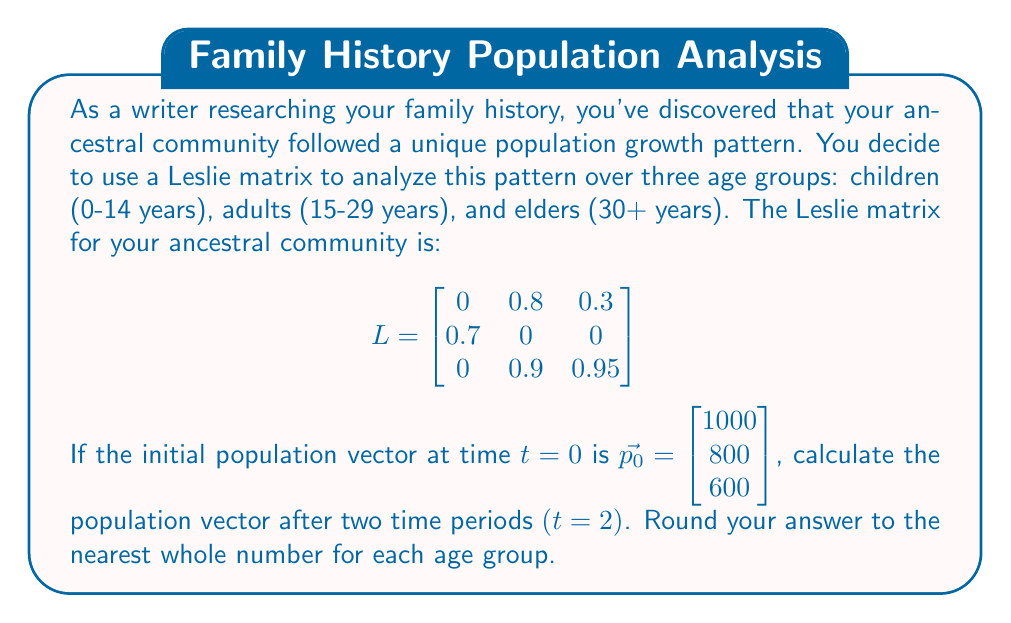Solve this math problem. To solve this problem, we need to multiply the Leslie matrix by the population vector twice, as we want to find the population after two time periods. Let's break it down step-by-step:

1) First, let's calculate the population after one time period $(t=1)$:

   $\vec{p_1} = L \cdot \vec{p_0}$

   $$\begin{bmatrix}
   0 & 0.8 & 0.3 \\
   0.7 & 0 & 0 \\
   0 & 0.9 & 0.95
   \end{bmatrix} \cdot \begin{bmatrix} 1000 \\ 800 \\ 600 \end{bmatrix}$$

   $$= \begin{bmatrix}
   (0 \cdot 1000) + (0.8 \cdot 800) + (0.3 \cdot 600) \\
   (0.7 \cdot 1000) + (0 \cdot 800) + (0 \cdot 600) \\
   (0 \cdot 1000) + (0.9 \cdot 800) + (0.95 \cdot 600)
   \end{bmatrix}$$

   $$= \begin{bmatrix} 820 \\ 700 \\ 1290 \end{bmatrix}$$

2) Now, let's calculate the population after two time periods $(t=2)$:

   $\vec{p_2} = L \cdot \vec{p_1}$

   $$\begin{bmatrix}
   0 & 0.8 & 0.3 \\
   0.7 & 0 & 0 \\
   0 & 0.9 & 0.95
   \end{bmatrix} \cdot \begin{bmatrix} 820 \\ 700 \\ 1290 \end{bmatrix}$$

   $$= \begin{bmatrix}
   (0 \cdot 820) + (0.8 \cdot 700) + (0.3 \cdot 1290) \\
   (0.7 \cdot 820) + (0 \cdot 700) + (0 \cdot 1290) \\
   (0 \cdot 820) + (0.9 \cdot 700) + (0.95 \cdot 1290)
   \end{bmatrix}$$

   $$= \begin{bmatrix} 947 \\ 574 \\ 1855.5 \end{bmatrix}$$

3) Rounding to the nearest whole number:

   $\vec{p_2} \approx \begin{bmatrix} 947 \\ 574 \\ 1856 \end{bmatrix}$
Answer: $\vec{p_2} = \begin{bmatrix} 947 \\ 574 \\ 1856 \end{bmatrix}$ 